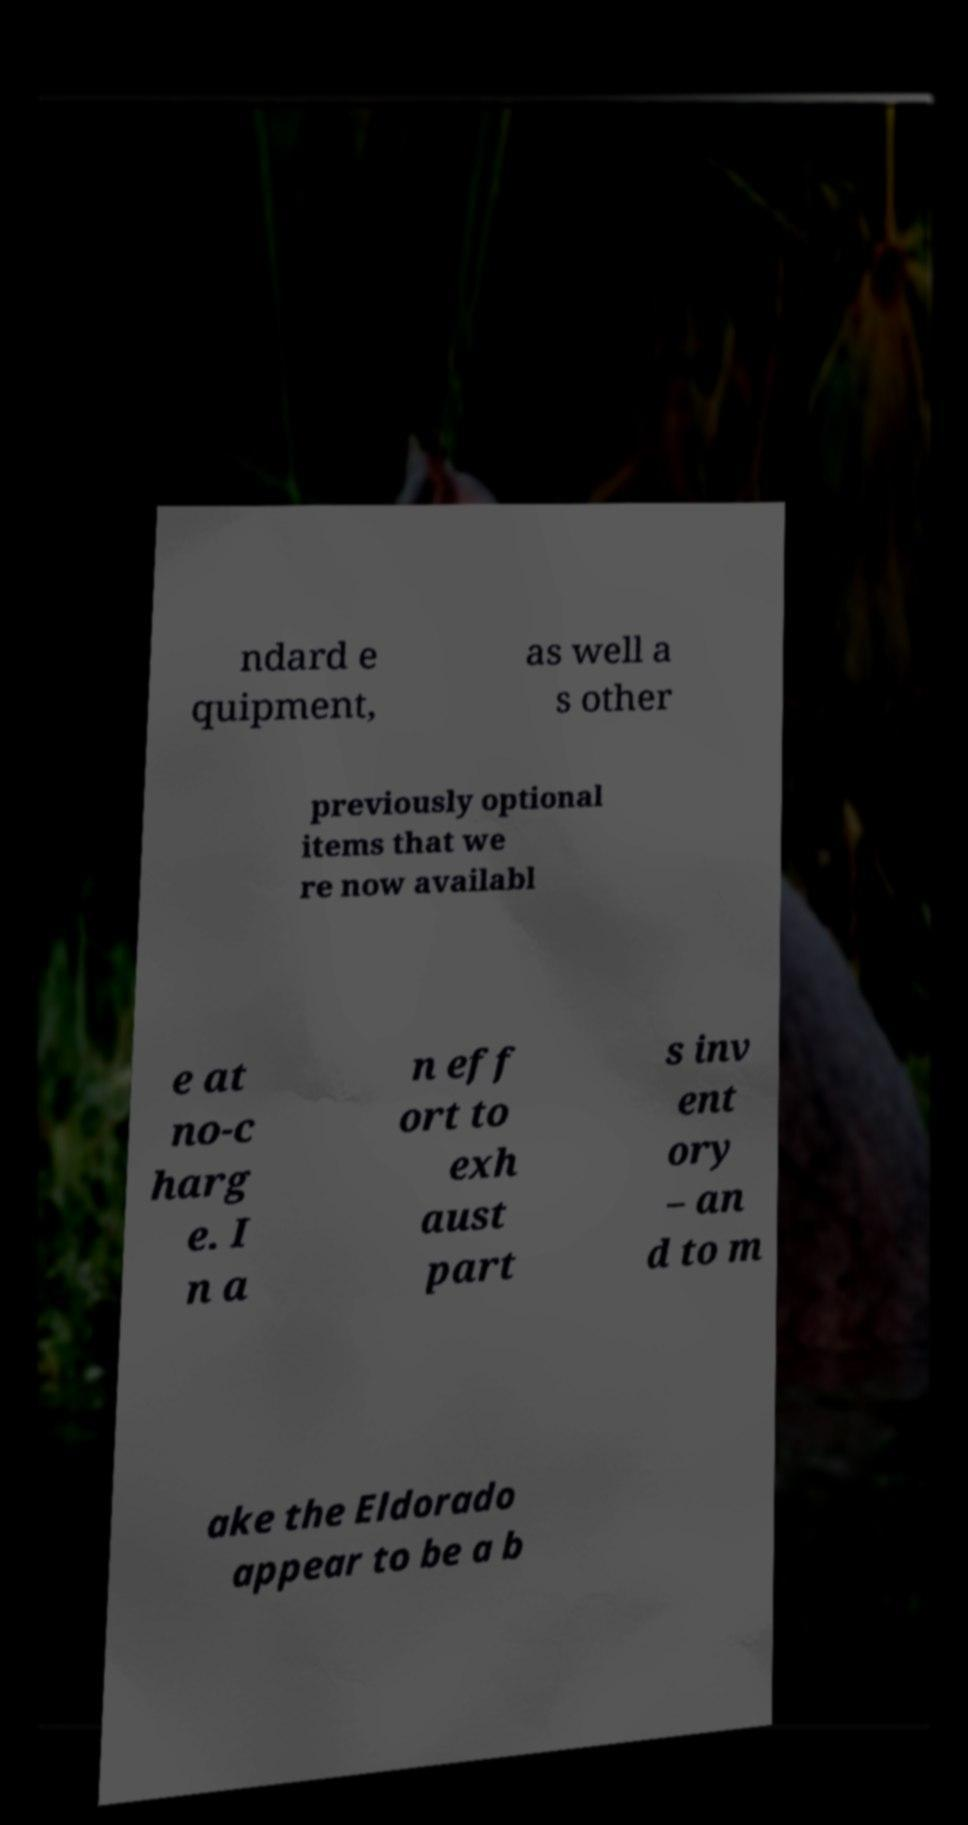Can you read and provide the text displayed in the image?This photo seems to have some interesting text. Can you extract and type it out for me? ndard e quipment, as well a s other previously optional items that we re now availabl e at no-c harg e. I n a n eff ort to exh aust part s inv ent ory – an d to m ake the Eldorado appear to be a b 